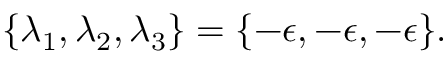<formula> <loc_0><loc_0><loc_500><loc_500>\{ \lambda _ { 1 } , \lambda _ { 2 } , \lambda _ { 3 } \} = \{ - \epsilon , - \epsilon , - \epsilon \} .</formula> 